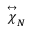<formula> <loc_0><loc_0><loc_500><loc_500>\stackrel { \leftrightarrow } { \chi } _ { N }</formula> 